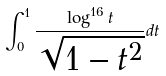Convert formula to latex. <formula><loc_0><loc_0><loc_500><loc_500>\int _ { 0 } ^ { 1 } \frac { \log ^ { 1 6 } t } { \sqrt { 1 - t ^ { 2 } } } d t</formula> 